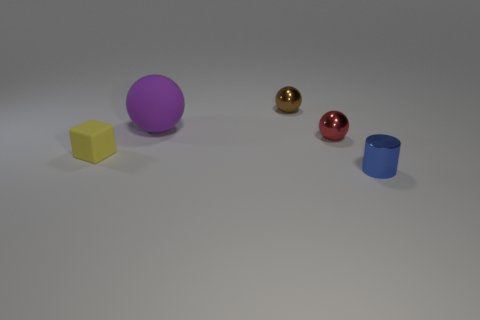What is the color of the small matte object?
Offer a terse response. Yellow. Are there more brown metallic spheres on the right side of the big purple thing than small brown shiny balls that are to the right of the metallic cylinder?
Make the answer very short. Yes. The small ball that is left of the red metal object is what color?
Ensure brevity in your answer.  Brown. There is a object that is in front of the small yellow cube; is it the same size as the rubber thing that is behind the small red metal ball?
Keep it short and to the point. No. How many objects are either large red matte cylinders or small yellow matte things?
Your answer should be compact. 1. There is a ball that is to the left of the metallic thing behind the red metallic object; what is it made of?
Provide a short and direct response. Rubber. How many other tiny objects have the same shape as the red metal thing?
Provide a short and direct response. 1. What number of objects are either tiny brown metal balls that are behind the small yellow matte block or small objects behind the large sphere?
Keep it short and to the point. 1. Are there any shiny things behind the rubber object to the right of the tiny rubber object?
Your answer should be compact. Yes. There is a blue metallic object that is the same size as the red ball; what shape is it?
Your answer should be compact. Cylinder. 